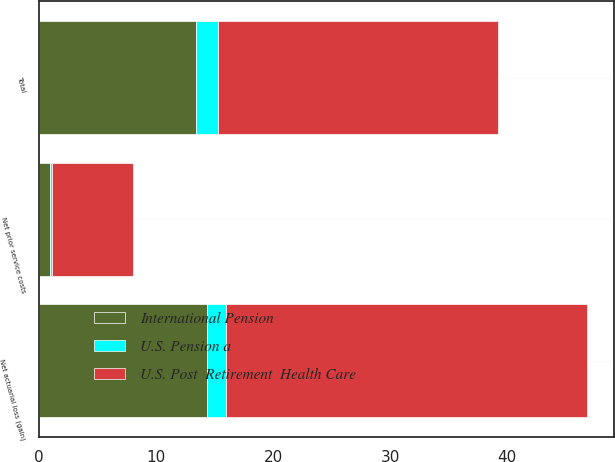Convert chart to OTSL. <chart><loc_0><loc_0><loc_500><loc_500><stacked_bar_chart><ecel><fcel>Net actuarial loss (gain)<fcel>Net prior service costs<fcel>Total<nl><fcel>U.S. Post  Retirement  Health Care<fcel>30.8<fcel>6.9<fcel>23.9<nl><fcel>International Pension<fcel>14.3<fcel>0.9<fcel>13.4<nl><fcel>U.S. Pension a<fcel>1.7<fcel>0.2<fcel>1.9<nl></chart> 